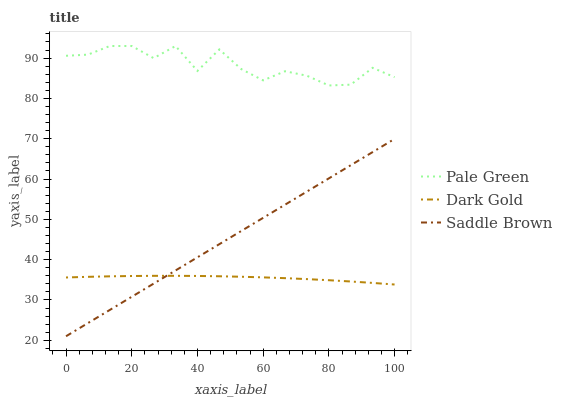Does Dark Gold have the minimum area under the curve?
Answer yes or no. Yes. Does Pale Green have the maximum area under the curve?
Answer yes or no. Yes. Does Saddle Brown have the minimum area under the curve?
Answer yes or no. No. Does Saddle Brown have the maximum area under the curve?
Answer yes or no. No. Is Saddle Brown the smoothest?
Answer yes or no. Yes. Is Pale Green the roughest?
Answer yes or no. Yes. Is Dark Gold the smoothest?
Answer yes or no. No. Is Dark Gold the roughest?
Answer yes or no. No. Does Saddle Brown have the lowest value?
Answer yes or no. Yes. Does Dark Gold have the lowest value?
Answer yes or no. No. Does Pale Green have the highest value?
Answer yes or no. Yes. Does Saddle Brown have the highest value?
Answer yes or no. No. Is Saddle Brown less than Pale Green?
Answer yes or no. Yes. Is Pale Green greater than Dark Gold?
Answer yes or no. Yes. Does Saddle Brown intersect Dark Gold?
Answer yes or no. Yes. Is Saddle Brown less than Dark Gold?
Answer yes or no. No. Is Saddle Brown greater than Dark Gold?
Answer yes or no. No. Does Saddle Brown intersect Pale Green?
Answer yes or no. No. 